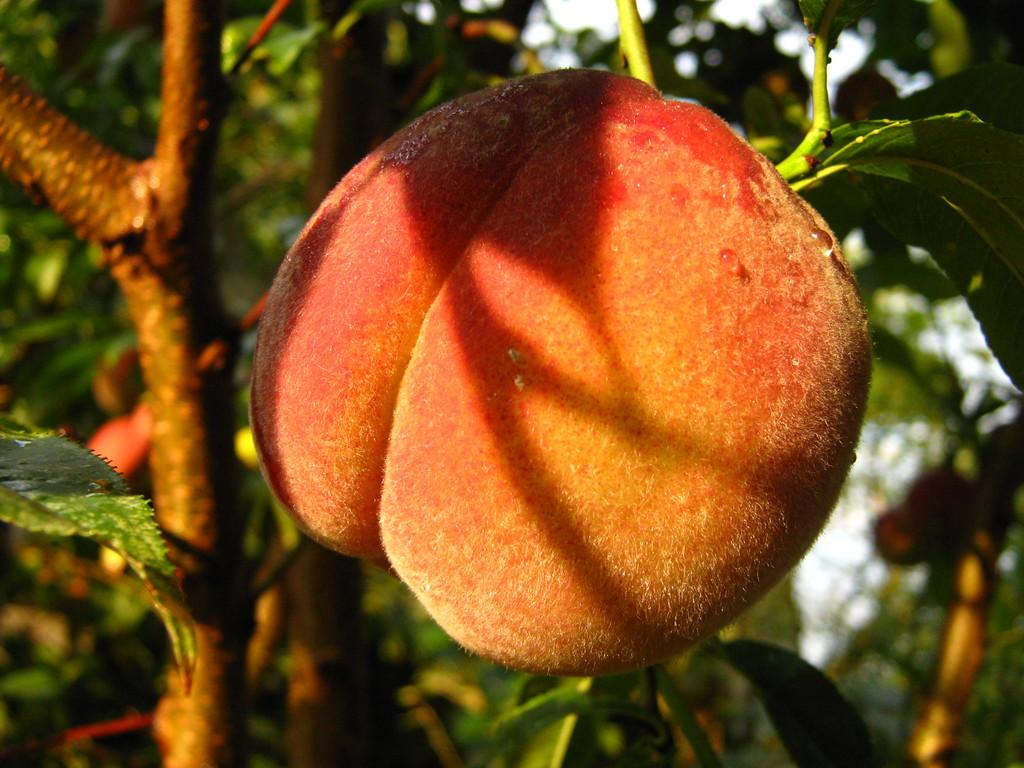What is the main subject in the center of the image? There is a fruit in the center of the image. What can be seen in the background of the image? There are stems and leaves of a tree in the background. What is the weather like in the image? It is a sunny scene. How is the background of the image depicted? The background is blurred. How many houses are visible in the image? There are no houses visible in the image; it features a fruit with a blurred background of tree stems and leaves. What type of calendar is hanging on the tree in the image? There is no calendar present in the image; it only features a fruit and tree stems and leaves. 